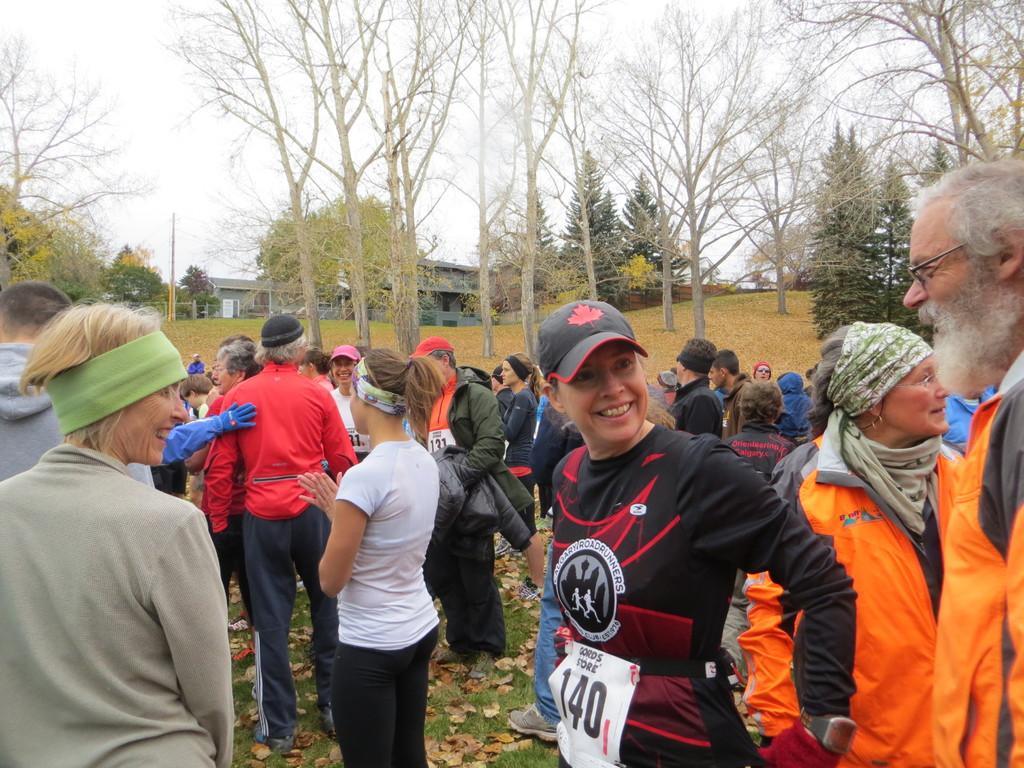Can you describe this image briefly? In this picture we can observe some people standing on the ground. There are men and women. In the background there are trees, houses and a sky. 